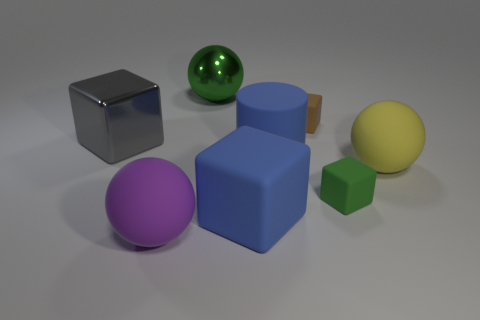What material is the object that is the same color as the rubber cylinder?
Offer a terse response. Rubber. Is the number of green cubes that are in front of the purple thing greater than the number of big yellow objects?
Provide a short and direct response. No. Do the large yellow object and the purple matte object have the same shape?
Provide a short and direct response. Yes. What number of big blue cylinders are made of the same material as the purple ball?
Keep it short and to the point. 1. There is a blue object that is the same shape as the tiny green object; what size is it?
Make the answer very short. Large. Is the number of gray matte cylinders the same as the number of yellow matte things?
Give a very brief answer. No. Is the green ball the same size as the brown matte cube?
Offer a terse response. No. There is a large shiny object in front of the green thing that is on the left side of the large blue rubber thing behind the small green block; what shape is it?
Provide a short and direct response. Cube. The large metal object that is the same shape as the small brown rubber object is what color?
Give a very brief answer. Gray. There is a ball that is behind the big purple rubber thing and in front of the large green thing; what size is it?
Your answer should be compact. Large. 